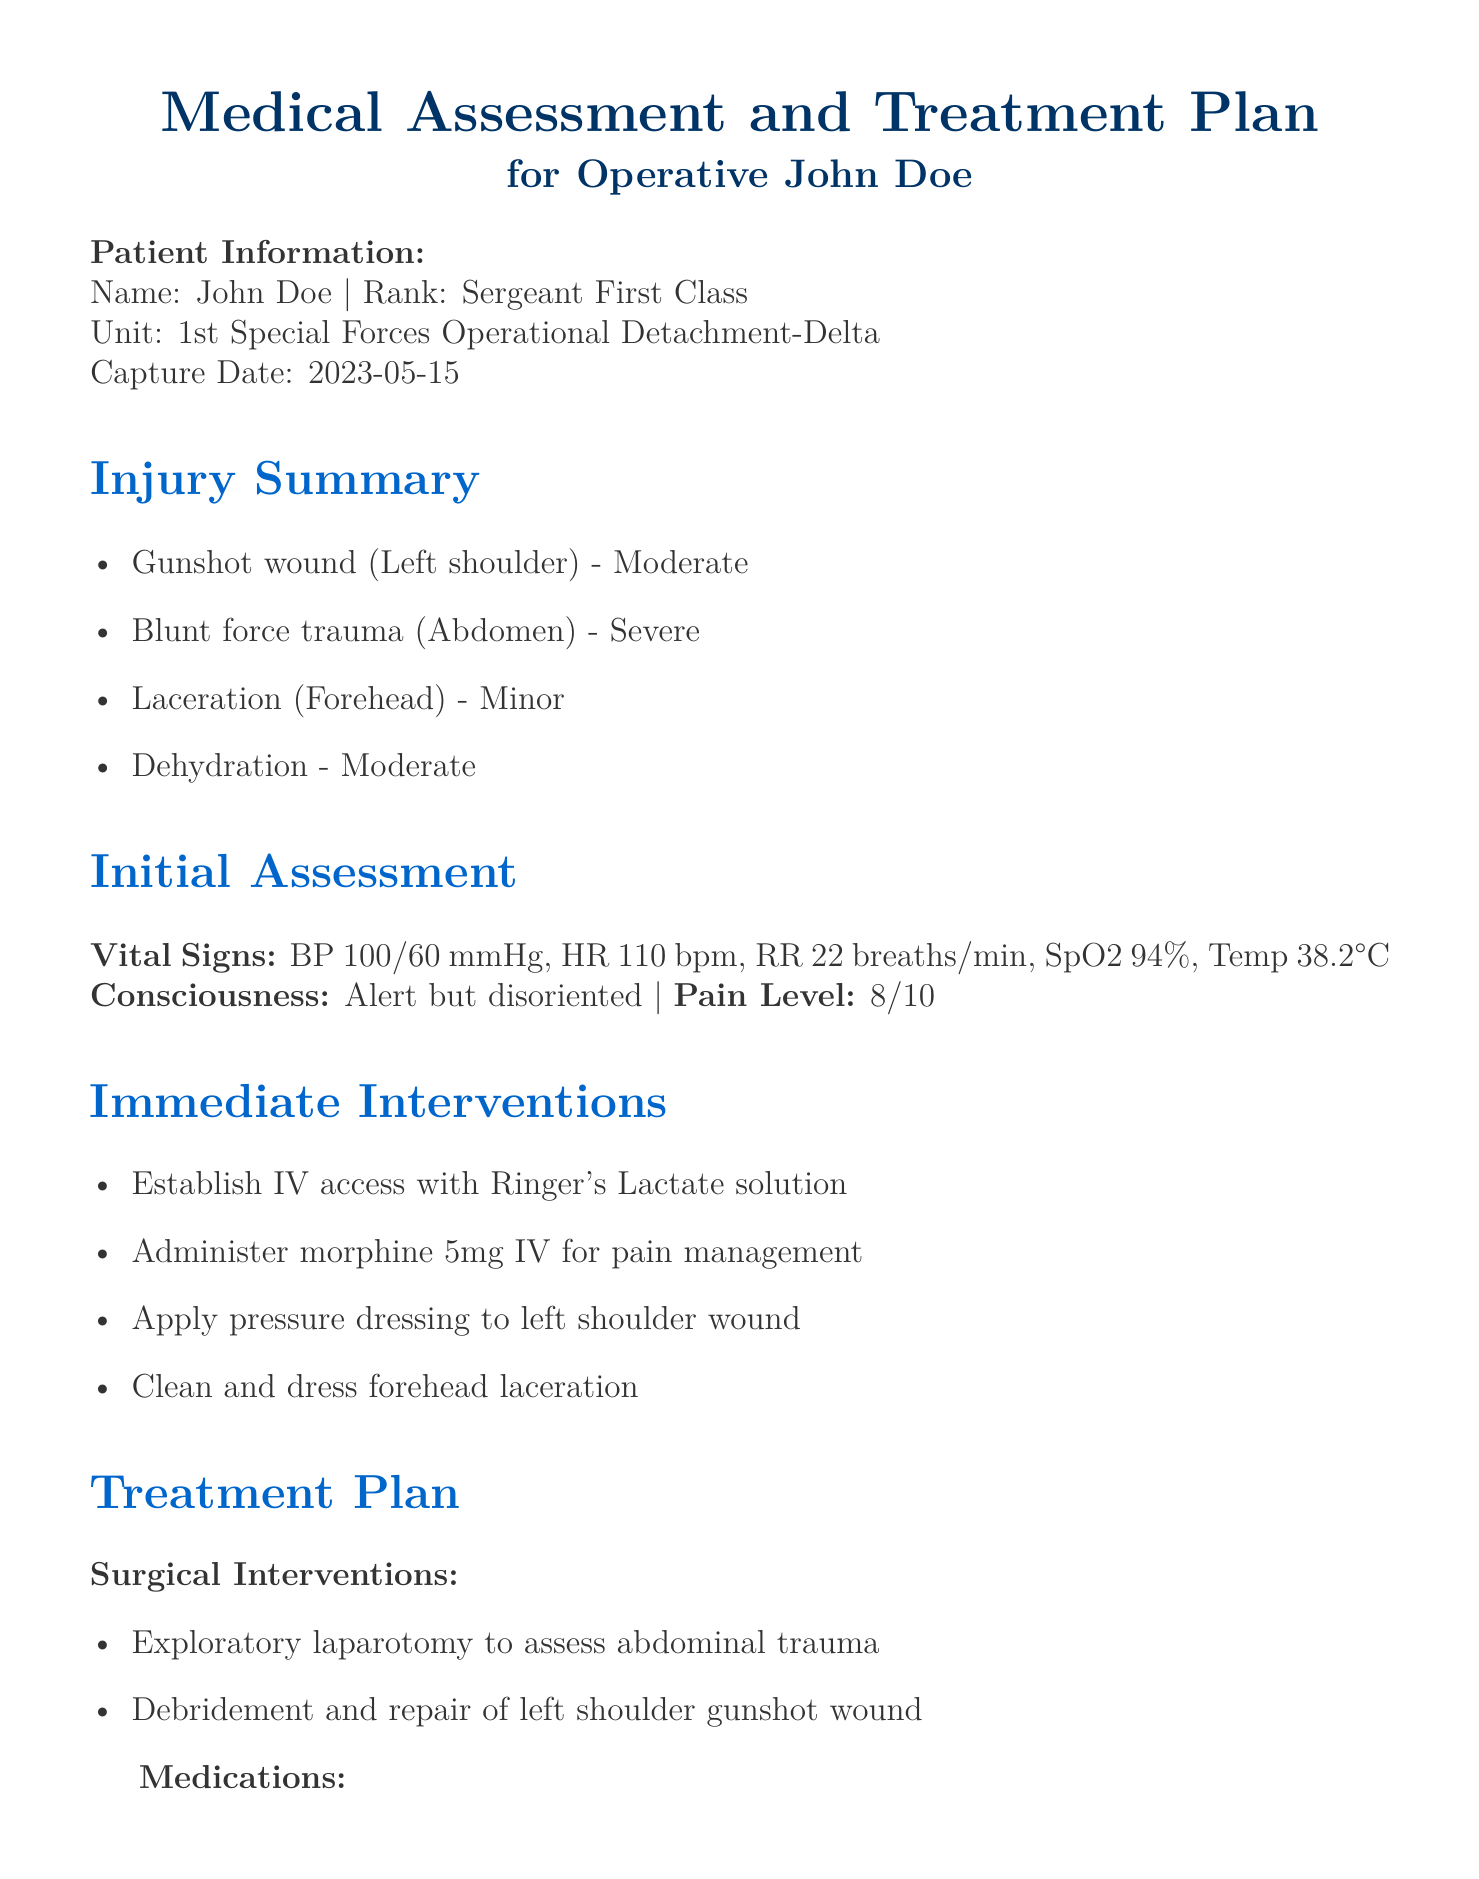What is the patient's name? The document provides specific information about the patient, including their name.
Answer: John Doe What type of injury is located in the left shoulder? The document outlines various injuries with specific locations; the left shoulder has a gunshot wound.
Answer: Gunshot wound What is the severity of the blunt force trauma? The document classifies the severity of multiple injuries, with blunt force trauma categorized as severe.
Answer: Severe What is the recommended timeline for evacuation? The evacuation plan specifies a recommended timeline for tasks based on the patient's condition.
Answer: Within 72 hours if stable What initial pain level is reported by the patient? The initial assessment includes the patient's reported pain level, which is mentioned.
Answer: 8/10 What type of psychological condition is screened for? The psychological support section identifies conditions that are assessed during treatment, which includes acute stress disorder.
Answer: Acute stress disorder What is the dosage for the prophylactic antibiotic? The medications section lists specific treatments and their dosages, including the prophylactic antibiotic.
Answer: 1g IV q12h How often are vital signs monitored in the first 24 hours? The monitoring plan details the frequency of vital sign checks during the initial recovery period.
Answer: Hourly 